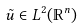Convert formula to latex. <formula><loc_0><loc_0><loc_500><loc_500>\tilde { u } \in L ^ { 2 } ( \mathbb { R } ^ { n } )</formula> 